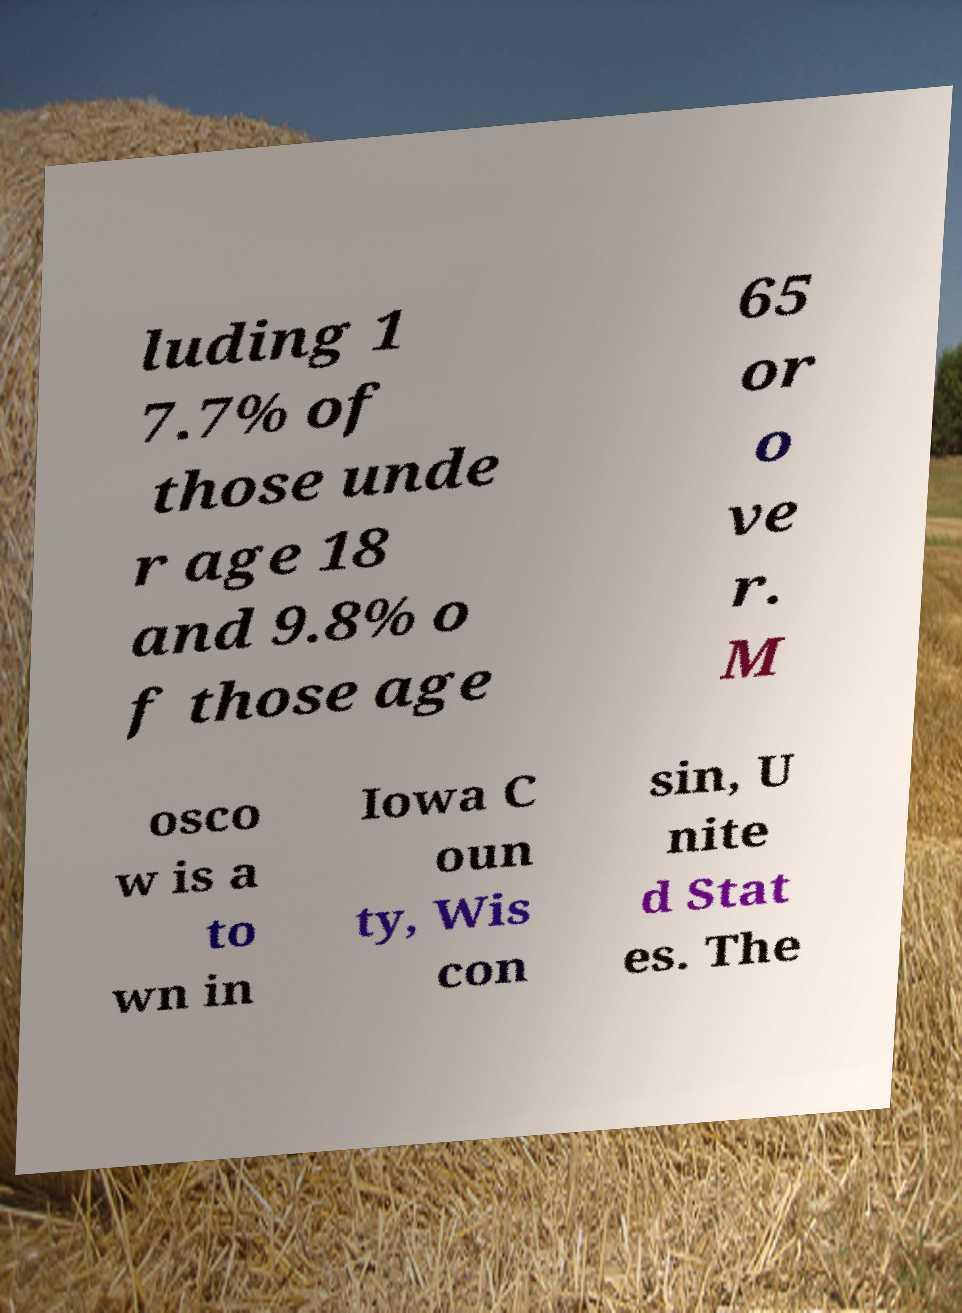What messages or text are displayed in this image? I need them in a readable, typed format. luding 1 7.7% of those unde r age 18 and 9.8% o f those age 65 or o ve r. M osco w is a to wn in Iowa C oun ty, Wis con sin, U nite d Stat es. The 